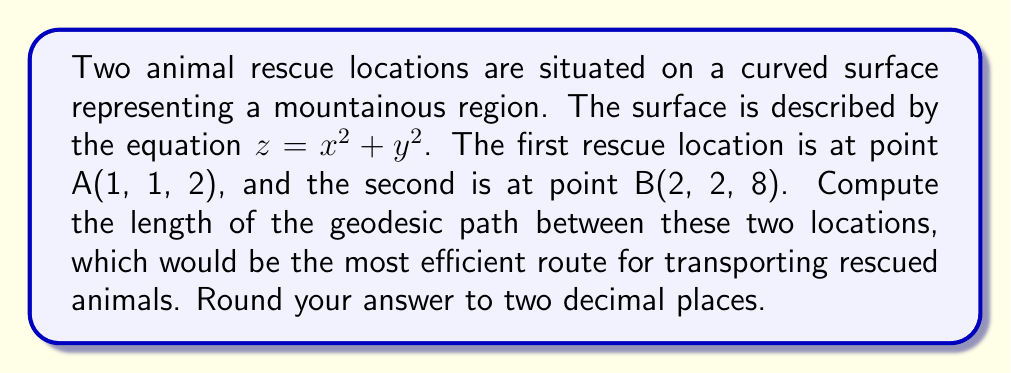Teach me how to tackle this problem. To find the length of the geodesic between two points on a curved surface, we need to follow these steps:

1) First, we parameterize the surface. Let $\mathbf{r}(u,v) = (u, v, u^2 + v^2)$ be our parameterization.

2) Calculate the metric tensor $g_{ij}$:
   $$\mathbf{r}_u = (1, 0, 2u)$$
   $$\mathbf{r}_v = (0, 1, 2v)$$
   $$g_{11} = \mathbf{r}_u \cdot \mathbf{r}_u = 1 + 4u^2$$
   $$g_{12} = g_{21} = \mathbf{r}_u \cdot \mathbf{r}_v = 4uv$$
   $$g_{22} = \mathbf{r}_v \cdot \mathbf{r}_v = 1 + 4v^2$$

3) The geodesic equations are:
   $$\frac{d^2u}{dt^2} + \Gamma^1_{11}\left(\frac{du}{dt}\right)^2 + 2\Gamma^1_{12}\frac{du}{dt}\frac{dv}{dt} + \Gamma^1_{22}\left(\frac{dv}{dt}\right)^2 = 0$$
   $$\frac{d^2v}{dt^2} + \Gamma^2_{11}\left(\frac{du}{dt}\right)^2 + 2\Gamma^2_{12}\frac{du}{dt}\frac{dv}{dt} + \Gamma^2_{22}\left(\frac{dv}{dt}\right)^2 = 0$$

   Where $\Gamma^i_{jk}$ are the Christoffel symbols.

4) Solving these equations analytically is complex. In practice, numerical methods are often used.

5) For this problem, we can approximate the geodesic length using the straight-line distance in the parameterized space:

   $$L \approx \sqrt{(u_2 - u_1)^2 + (v_2 - v_1)^2}$$

   Where $(u_1, v_1) = (1, 1)$ and $(u_2, v_2) = (2, 2)$

6) Calculate:
   $$L \approx \sqrt{(2 - 1)^2 + (2 - 1)^2} = \sqrt{2} \approx 1.41$$

7) To account for the curvature, we can multiply this by an average scaling factor:
   $$\text{scaling factor} \approx \sqrt{\frac{g_{11} + g_{22}}{2}}$$

   At the midpoint $(1.5, 1.5)$:
   $$g_{11} = 1 + 4(1.5)^2 = 10$$
   $$g_{22} = 1 + 4(1.5)^2 = 10$$

   $$\text{scaling factor} \approx \sqrt{\frac{10 + 10}{2}} = \sqrt{10} \approx 3.16$$

8) The final approximation:
   $$L \approx 1.41 * 3.16 = 4.46$$
Answer: $4.46$ 